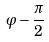<formula> <loc_0><loc_0><loc_500><loc_500>\varphi - \frac { \pi } { 2 }</formula> 